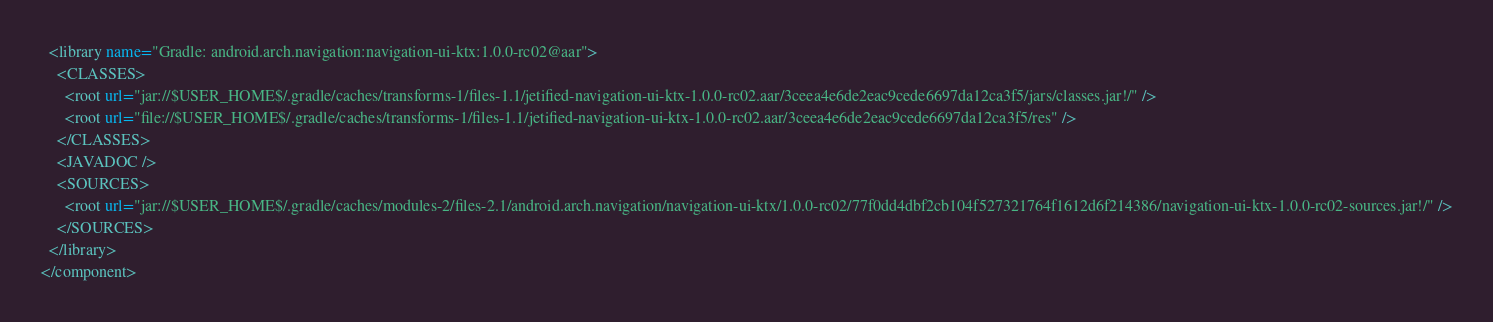Convert code to text. <code><loc_0><loc_0><loc_500><loc_500><_XML_>  <library name="Gradle: android.arch.navigation:navigation-ui-ktx:1.0.0-rc02@aar">
    <CLASSES>
      <root url="jar://$USER_HOME$/.gradle/caches/transforms-1/files-1.1/jetified-navigation-ui-ktx-1.0.0-rc02.aar/3ceea4e6de2eac9cede6697da12ca3f5/jars/classes.jar!/" />
      <root url="file://$USER_HOME$/.gradle/caches/transforms-1/files-1.1/jetified-navigation-ui-ktx-1.0.0-rc02.aar/3ceea4e6de2eac9cede6697da12ca3f5/res" />
    </CLASSES>
    <JAVADOC />
    <SOURCES>
      <root url="jar://$USER_HOME$/.gradle/caches/modules-2/files-2.1/android.arch.navigation/navigation-ui-ktx/1.0.0-rc02/77f0dd4dbf2cb104f527321764f1612d6f214386/navigation-ui-ktx-1.0.0-rc02-sources.jar!/" />
    </SOURCES>
  </library>
</component></code> 